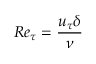<formula> <loc_0><loc_0><loc_500><loc_500>R e _ { \tau } = \frac { u _ { \tau } \delta } { \nu }</formula> 